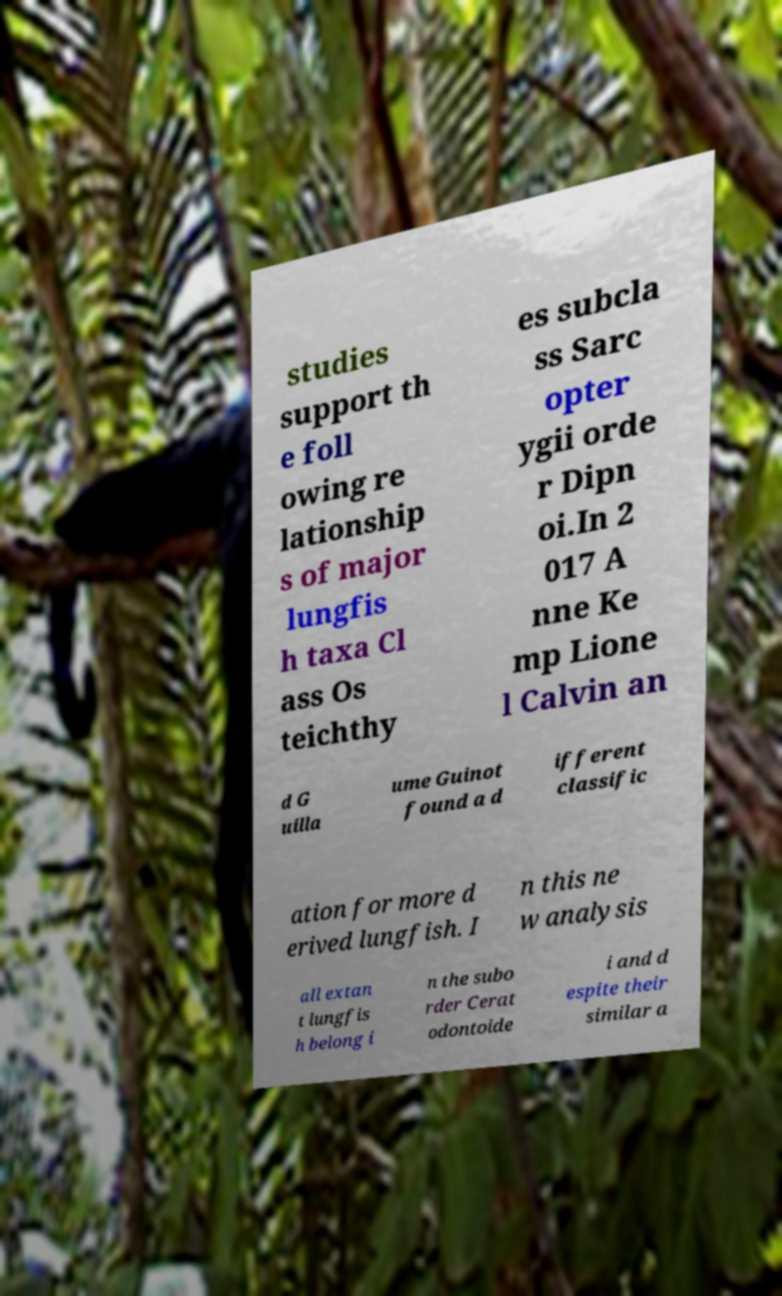Can you accurately transcribe the text from the provided image for me? studies support th e foll owing re lationship s of major lungfis h taxa Cl ass Os teichthy es subcla ss Sarc opter ygii orde r Dipn oi.In 2 017 A nne Ke mp Lione l Calvin an d G uilla ume Guinot found a d ifferent classific ation for more d erived lungfish. I n this ne w analysis all extan t lungfis h belong i n the subo rder Cerat odontoide i and d espite their similar a 